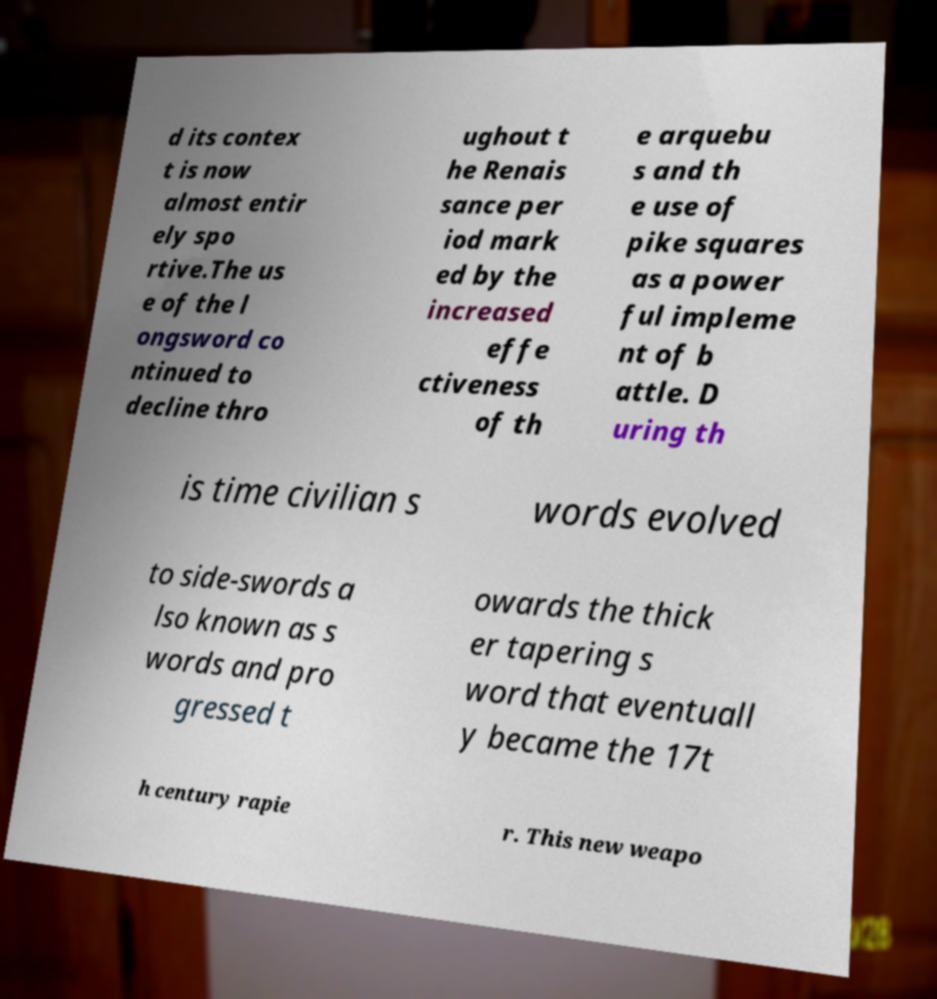For documentation purposes, I need the text within this image transcribed. Could you provide that? d its contex t is now almost entir ely spo rtive.The us e of the l ongsword co ntinued to decline thro ughout t he Renais sance per iod mark ed by the increased effe ctiveness of th e arquebu s and th e use of pike squares as a power ful impleme nt of b attle. D uring th is time civilian s words evolved to side-swords a lso known as s words and pro gressed t owards the thick er tapering s word that eventuall y became the 17t h century rapie r. This new weapo 